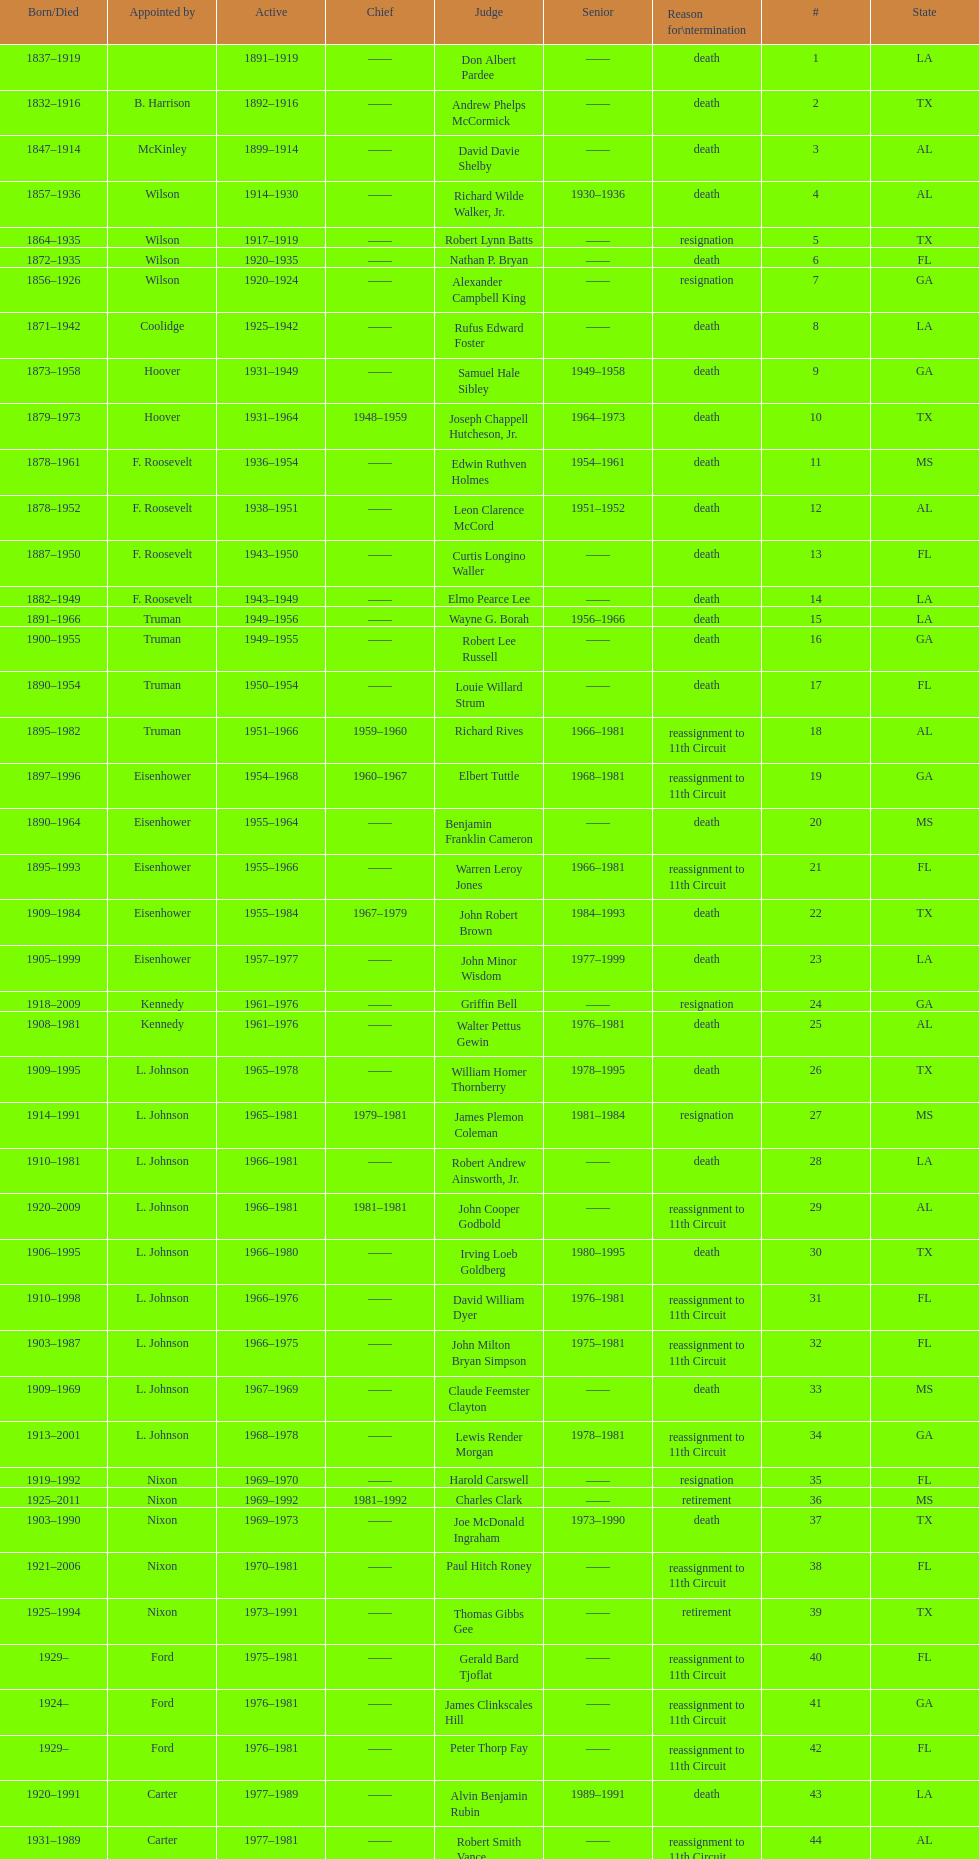Parse the full table. {'header': ['Born/Died', 'Appointed by', 'Active', 'Chief', 'Judge', 'Senior', 'Reason for\\ntermination', '#', 'State'], 'rows': [['1837–1919', '', '1891–1919', '——', 'Don Albert Pardee', '——', 'death', '1', 'LA'], ['1832–1916', 'B. Harrison', '1892–1916', '——', 'Andrew Phelps McCormick', '——', 'death', '2', 'TX'], ['1847–1914', 'McKinley', '1899–1914', '——', 'David Davie Shelby', '——', 'death', '3', 'AL'], ['1857–1936', 'Wilson', '1914–1930', '——', 'Richard Wilde Walker, Jr.', '1930–1936', 'death', '4', 'AL'], ['1864–1935', 'Wilson', '1917–1919', '——', 'Robert Lynn Batts', '——', 'resignation', '5', 'TX'], ['1872–1935', 'Wilson', '1920–1935', '——', 'Nathan P. Bryan', '——', 'death', '6', 'FL'], ['1856–1926', 'Wilson', '1920–1924', '——', 'Alexander Campbell King', '——', 'resignation', '7', 'GA'], ['1871–1942', 'Coolidge', '1925–1942', '——', 'Rufus Edward Foster', '——', 'death', '8', 'LA'], ['1873–1958', 'Hoover', '1931–1949', '——', 'Samuel Hale Sibley', '1949–1958', 'death', '9', 'GA'], ['1879–1973', 'Hoover', '1931–1964', '1948–1959', 'Joseph Chappell Hutcheson, Jr.', '1964–1973', 'death', '10', 'TX'], ['1878–1961', 'F. Roosevelt', '1936–1954', '——', 'Edwin Ruthven Holmes', '1954–1961', 'death', '11', 'MS'], ['1878–1952', 'F. Roosevelt', '1938–1951', '——', 'Leon Clarence McCord', '1951–1952', 'death', '12', 'AL'], ['1887–1950', 'F. Roosevelt', '1943–1950', '——', 'Curtis Longino Waller', '——', 'death', '13', 'FL'], ['1882–1949', 'F. Roosevelt', '1943–1949', '——', 'Elmo Pearce Lee', '——', 'death', '14', 'LA'], ['1891–1966', 'Truman', '1949–1956', '——', 'Wayne G. Borah', '1956–1966', 'death', '15', 'LA'], ['1900–1955', 'Truman', '1949–1955', '——', 'Robert Lee Russell', '——', 'death', '16', 'GA'], ['1890–1954', 'Truman', '1950–1954', '——', 'Louie Willard Strum', '——', 'death', '17', 'FL'], ['1895–1982', 'Truman', '1951–1966', '1959–1960', 'Richard Rives', '1966–1981', 'reassignment to 11th Circuit', '18', 'AL'], ['1897–1996', 'Eisenhower', '1954–1968', '1960–1967', 'Elbert Tuttle', '1968–1981', 'reassignment to 11th Circuit', '19', 'GA'], ['1890–1964', 'Eisenhower', '1955–1964', '——', 'Benjamin Franklin Cameron', '——', 'death', '20', 'MS'], ['1895–1993', 'Eisenhower', '1955–1966', '——', 'Warren Leroy Jones', '1966–1981', 'reassignment to 11th Circuit', '21', 'FL'], ['1909–1984', 'Eisenhower', '1955–1984', '1967–1979', 'John Robert Brown', '1984–1993', 'death', '22', 'TX'], ['1905–1999', 'Eisenhower', '1957–1977', '——', 'John Minor Wisdom', '1977–1999', 'death', '23', 'LA'], ['1918–2009', 'Kennedy', '1961–1976', '——', 'Griffin Bell', '——', 'resignation', '24', 'GA'], ['1908–1981', 'Kennedy', '1961–1976', '——', 'Walter Pettus Gewin', '1976–1981', 'death', '25', 'AL'], ['1909–1995', 'L. Johnson', '1965–1978', '——', 'William Homer Thornberry', '1978–1995', 'death', '26', 'TX'], ['1914–1991', 'L. Johnson', '1965–1981', '1979–1981', 'James Plemon Coleman', '1981–1984', 'resignation', '27', 'MS'], ['1910–1981', 'L. Johnson', '1966–1981', '——', 'Robert Andrew Ainsworth, Jr.', '——', 'death', '28', 'LA'], ['1920–2009', 'L. Johnson', '1966–1981', '1981–1981', 'John Cooper Godbold', '——', 'reassignment to 11th Circuit', '29', 'AL'], ['1906–1995', 'L. Johnson', '1966–1980', '——', 'Irving Loeb Goldberg', '1980–1995', 'death', '30', 'TX'], ['1910–1998', 'L. Johnson', '1966–1976', '——', 'David William Dyer', '1976–1981', 'reassignment to 11th Circuit', '31', 'FL'], ['1903–1987', 'L. Johnson', '1966–1975', '——', 'John Milton Bryan Simpson', '1975–1981', 'reassignment to 11th Circuit', '32', 'FL'], ['1909–1969', 'L. Johnson', '1967–1969', '——', 'Claude Feemster Clayton', '——', 'death', '33', 'MS'], ['1913–2001', 'L. Johnson', '1968–1978', '——', 'Lewis Render Morgan', '1978–1981', 'reassignment to 11th Circuit', '34', 'GA'], ['1919–1992', 'Nixon', '1969–1970', '——', 'Harold Carswell', '——', 'resignation', '35', 'FL'], ['1925–2011', 'Nixon', '1969–1992', '1981–1992', 'Charles Clark', '——', 'retirement', '36', 'MS'], ['1903–1990', 'Nixon', '1969–1973', '——', 'Joe McDonald Ingraham', '1973–1990', 'death', '37', 'TX'], ['1921–2006', 'Nixon', '1970–1981', '——', 'Paul Hitch Roney', '——', 'reassignment to 11th Circuit', '38', 'FL'], ['1925–1994', 'Nixon', '1973–1991', '——', 'Thomas Gibbs Gee', '——', 'retirement', '39', 'TX'], ['1929–', 'Ford', '1975–1981', '——', 'Gerald Bard Tjoflat', '——', 'reassignment to 11th Circuit', '40', 'FL'], ['1924–', 'Ford', '1976–1981', '——', 'James Clinkscales Hill', '——', 'reassignment to 11th Circuit', '41', 'GA'], ['1929–', 'Ford', '1976–1981', '——', 'Peter Thorp Fay', '——', 'reassignment to 11th Circuit', '42', 'FL'], ['1920–1991', 'Carter', '1977–1989', '——', 'Alvin Benjamin Rubin', '1989–1991', 'death', '43', 'LA'], ['1931–1989', 'Carter', '1977–1981', '——', 'Robert Smith Vance', '——', 'reassignment to 11th Circuit', '44', 'AL'], ['1920–', 'Carter', '1979–1981', '——', 'Phyllis A. Kravitch', '——', 'reassignment to 11th Circuit', '45', 'GA'], ['1918–1999', 'Carter', '1979–1981', '——', 'Frank Minis Johnson', '——', 'reassignment to 11th Circuit', '46', 'AL'], ['1936–', 'Carter', '1979–1981', '——', 'R. Lanier Anderson III', '——', 'reassignment to 11th Circuit', '47', 'GA'], ['1915–2004', 'Carter', '1979–1982', '——', 'Reynaldo Guerra Garza', '1982–2004', 'death', '48', 'TX'], ['1932–', 'Carter', '1979–1981', '——', 'Joseph Woodrow Hatchett', '——', 'reassignment to 11th Circuit', '49', 'FL'], ['1920–1999', 'Carter', '1979–1981', '——', 'Albert John Henderson', '——', 'reassignment to 11th Circuit', '50', 'GA'], ['1932–2002', 'Carter', '1979–1999', '1992–1999', 'Henry Anthony Politz', '1999–2002', 'death', '52', 'LA'], ['1920–2002', 'Carter', '1979–1991', '——', 'Samuel D. Johnson, Jr.', '1991–2002', 'death', '54', 'TX'], ['1920–1986', 'Carter', '1979–1986', '——', 'Albert Tate, Jr.', '——', 'death', '55', 'LA'], ['1920–2005', 'Carter', '1979–1981', '——', 'Thomas Alonzo Clark', '——', 'reassignment to 11th Circuit', '56', 'GA'], ['1916–1993', 'Carter', '1980–1990', '——', 'Jerre Stockton Williams', '1990–1993', 'death', '57', 'TX'], ['1931–2011', 'Reagan', '1981–1997', '——', 'William Lockhart Garwood', '1997–2011', 'death', '58', 'TX'], ['1928–1987', 'Reagan', '1984–1987', '——', 'Robert Madden Hill', '——', 'death', '62', 'TX'], ['1933-', 'Reagan', '1988–1999', '——', 'John Malcolm Duhé, Jr.', '1999–2011', 'retirement', '65', 'LA'], ['1937–', 'Clinton', '1994–2002', '——', 'Robert Manley Parker', '——', 'retirement', '72', 'TX'], ['1937–', 'G.W. Bush', '2004–2004', '——', 'Charles W. Pickering', '——', 'retirement', '76', 'MS']]} Name a state listed at least 4 times. TX. 